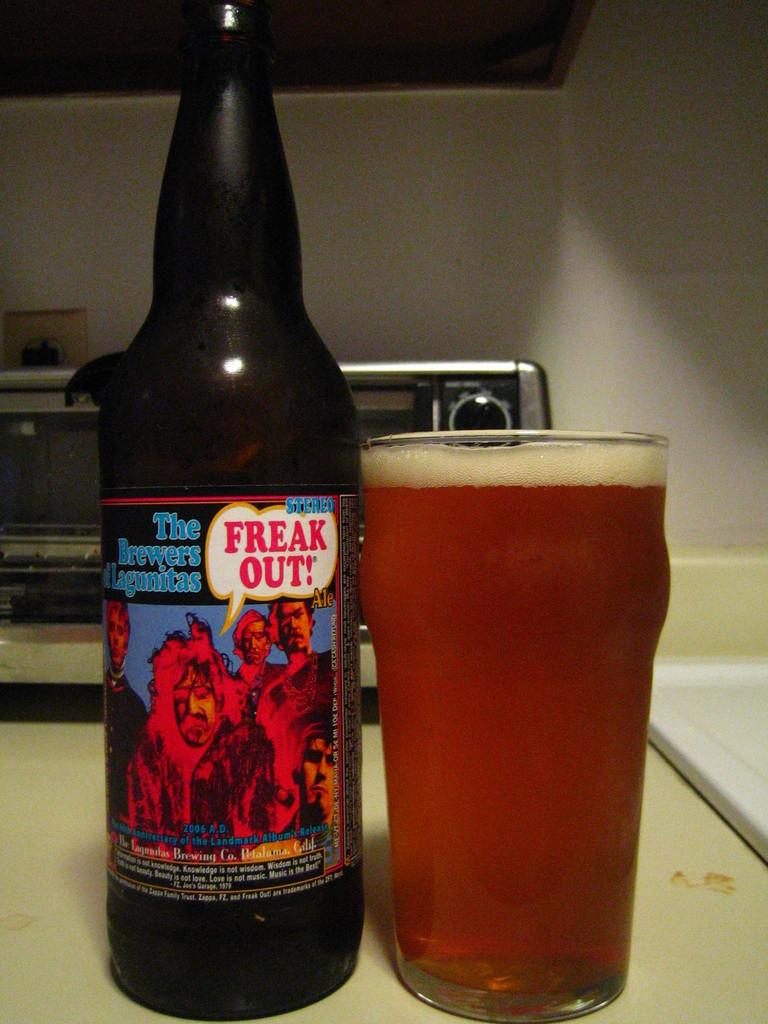<image>
Share a concise interpretation of the image provided. A bottle of Freak Out Beer is next to a glass. 